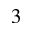<formula> <loc_0><loc_0><loc_500><loc_500>_ { 3 }</formula> 